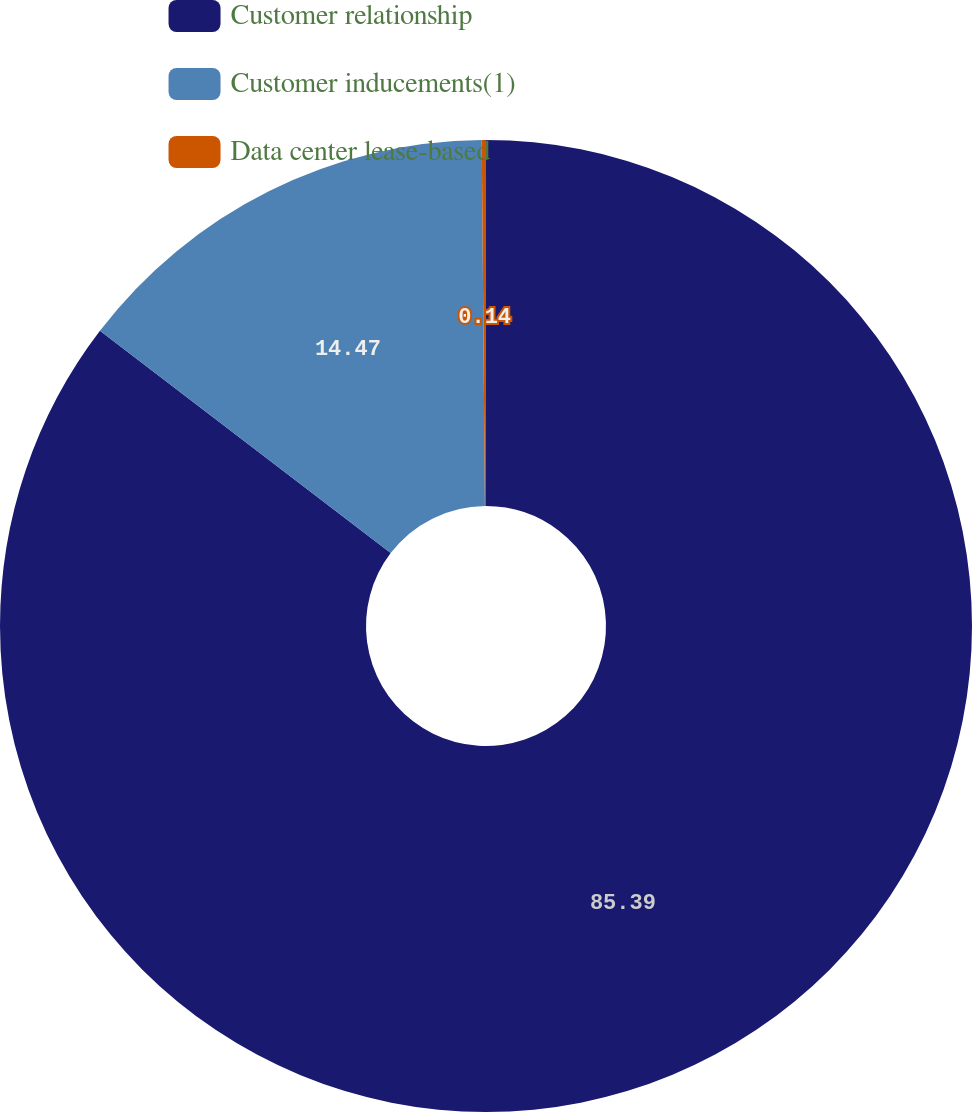Convert chart. <chart><loc_0><loc_0><loc_500><loc_500><pie_chart><fcel>Customer relationship<fcel>Customer inducements(1)<fcel>Data center lease-based<nl><fcel>85.39%<fcel>14.47%<fcel>0.14%<nl></chart> 